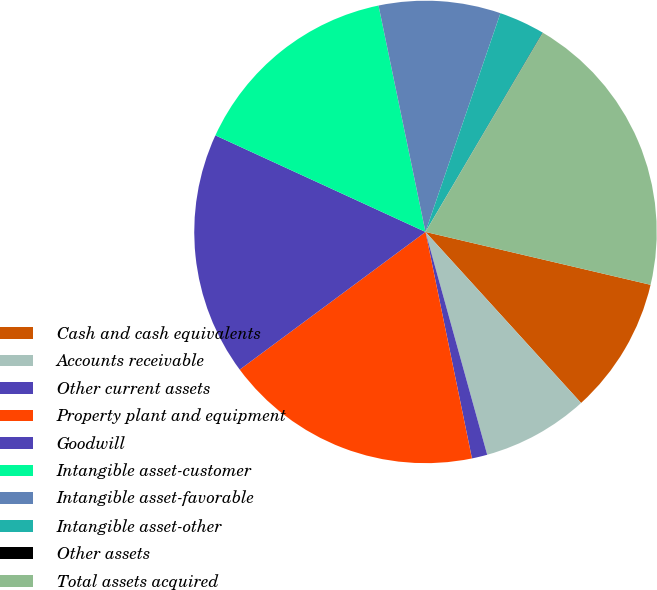<chart> <loc_0><loc_0><loc_500><loc_500><pie_chart><fcel>Cash and cash equivalents<fcel>Accounts receivable<fcel>Other current assets<fcel>Property plant and equipment<fcel>Goodwill<fcel>Intangible asset-customer<fcel>Intangible asset-favorable<fcel>Intangible asset-other<fcel>Other assets<fcel>Total assets acquired<nl><fcel>9.58%<fcel>7.45%<fcel>1.08%<fcel>18.07%<fcel>17.01%<fcel>14.89%<fcel>8.51%<fcel>3.2%<fcel>0.02%<fcel>20.2%<nl></chart> 